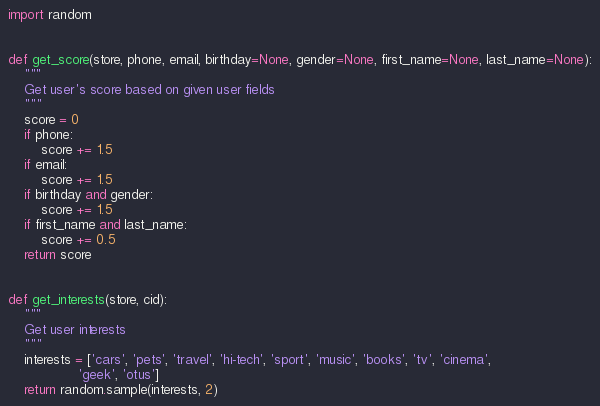Convert code to text. <code><loc_0><loc_0><loc_500><loc_500><_Python_>import random


def get_score(store, phone, email, birthday=None, gender=None, first_name=None, last_name=None):
    """
    Get user's score based on given user fields
    """
    score = 0
    if phone:
        score += 1.5
    if email:
        score += 1.5
    if birthday and gender:
        score += 1.5
    if first_name and last_name:
        score += 0.5
    return score


def get_interests(store, cid):
    """
    Get user interests
    """
    interests = ['cars', 'pets', 'travel', 'hi-tech', 'sport', 'music', 'books', 'tv', 'cinema',
                 'geek', 'otus']
    return random.sample(interests, 2)
</code> 